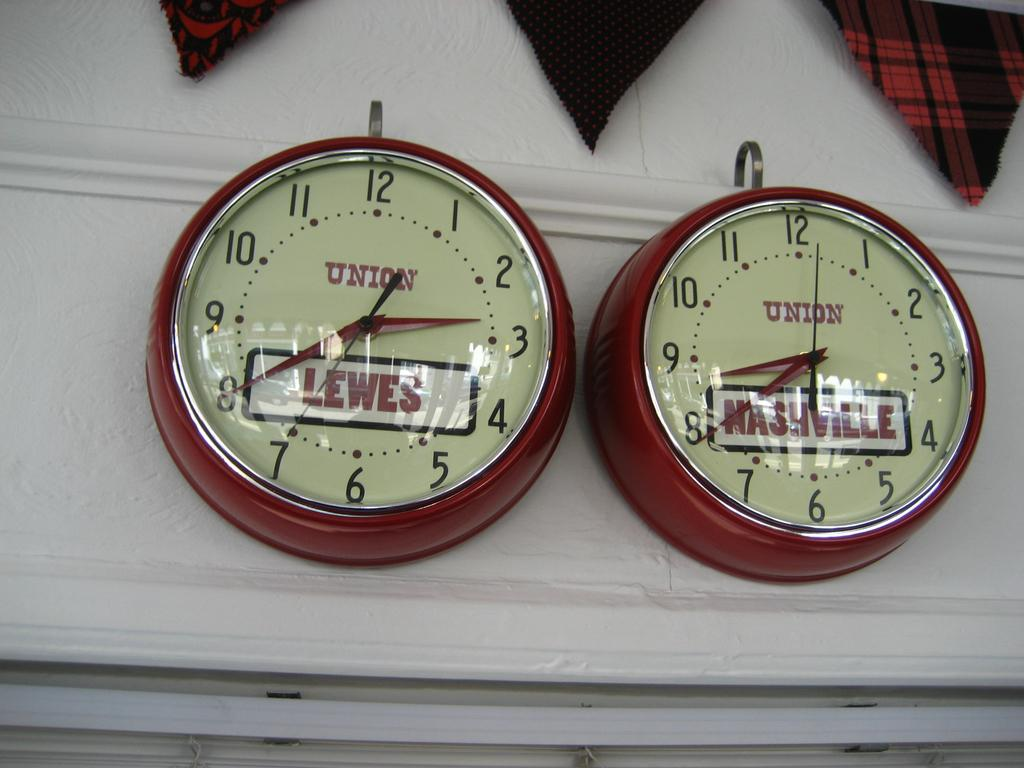<image>
Provide a brief description of the given image. Two red and white wall clocks display signs for Nashville and Lewes. 